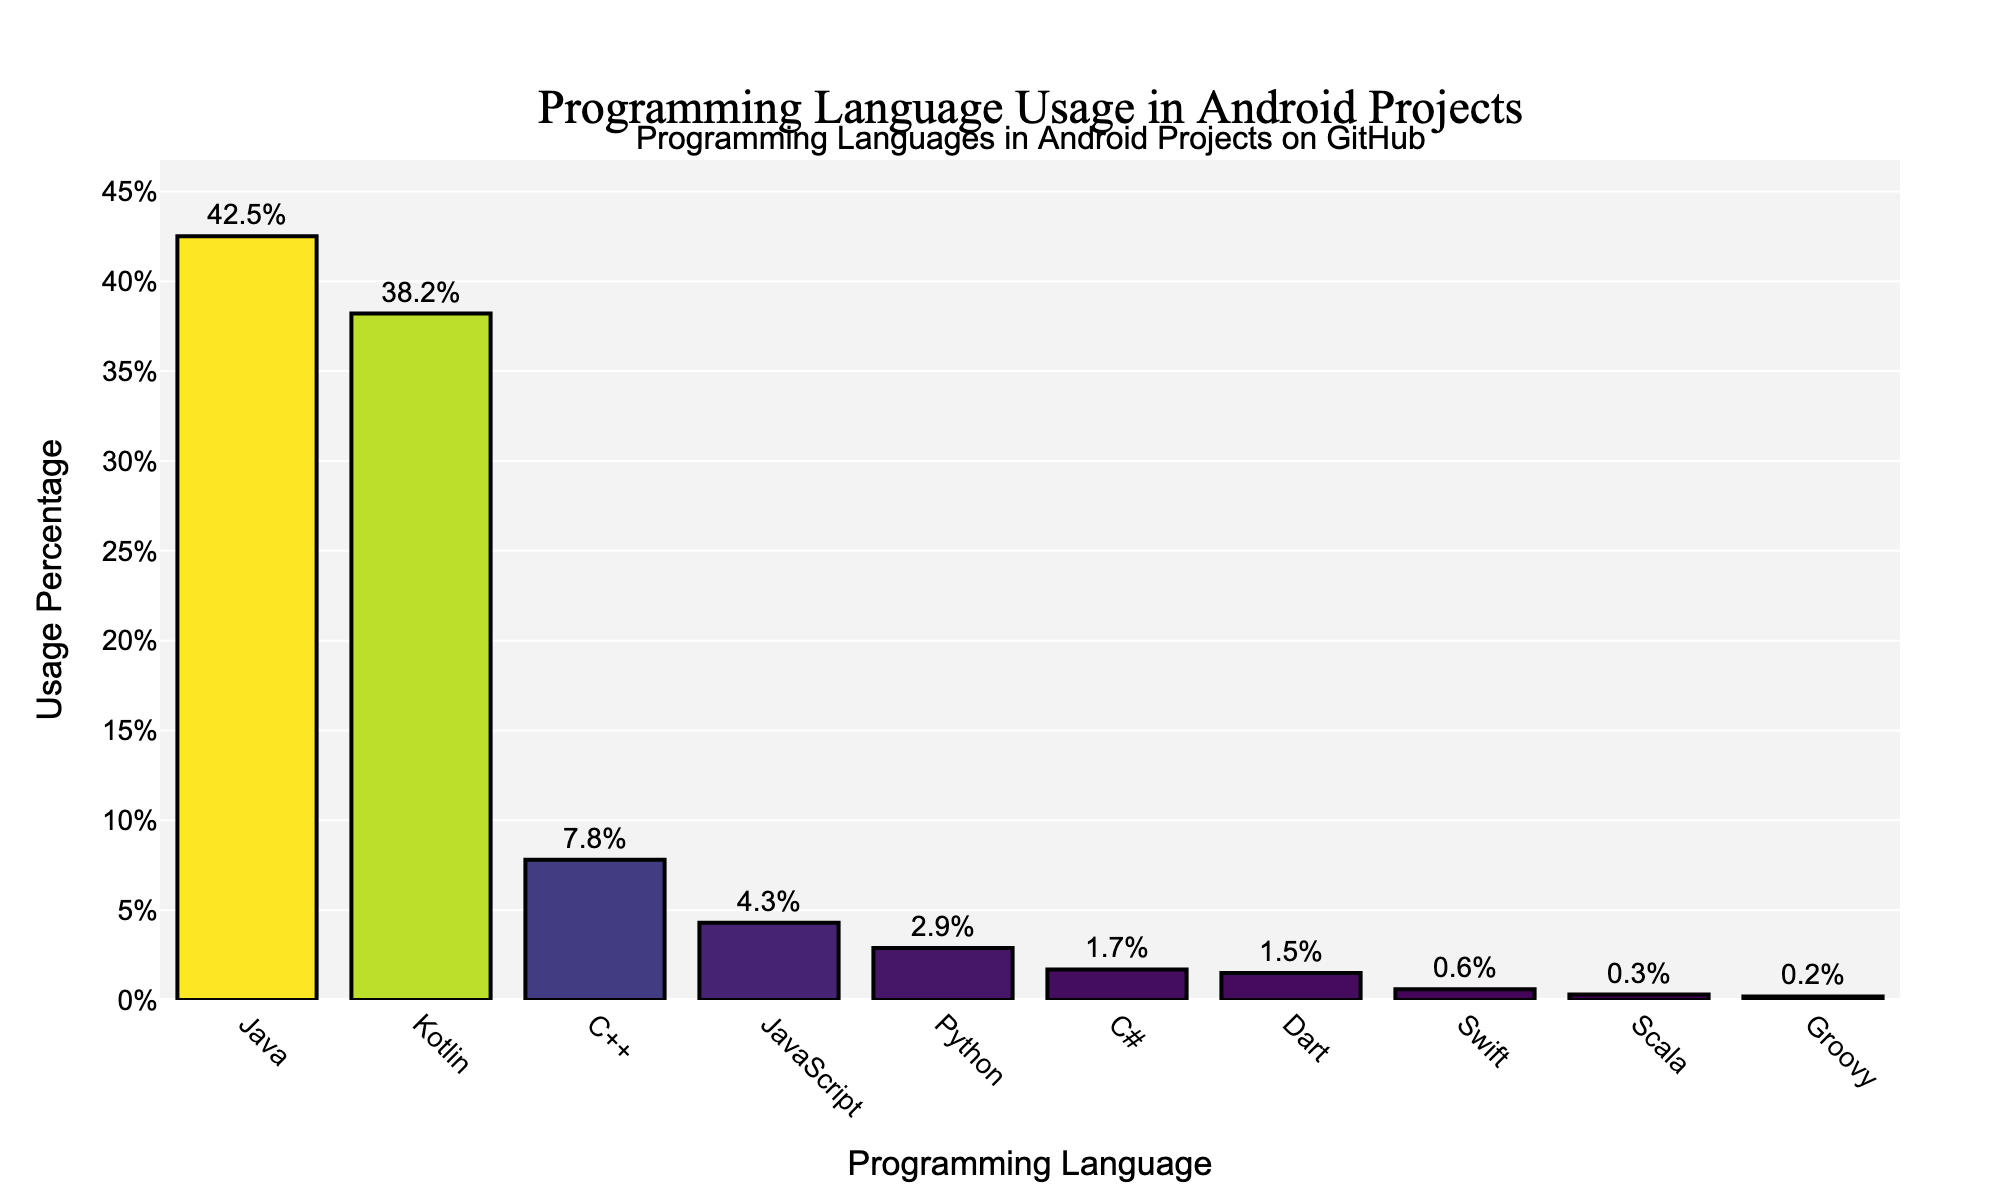Which programming language has the highest usage percentage in Android projects on GitHub? Java has the highest usage percentage as indicated by the tallest bar in the chart.
Answer: Java Which language comes second in terms of usage percentage? The second tallest bar represents the language, which is Kotlin.
Answer: Kotlin Which two languages together make up more than 80% of the usage percentages? Adding the percentages of Java (42.5%) and Kotlin (38.2%) gives 42.5 + 38.2 = 80.7%, which is more than 80%.
Answer: Java and Kotlin What is the difference in usage percentage between Java and Kotlin? The difference is calculated by subtracting Kotlin's percentage (38.2%) from Java's percentage (42.5%): 42.5 - 38.2 = 4.3%.
Answer: 4.3% How many languages have a usage percentage lower than 10%? Counting the bars with heights representing less than 10% gives the languages: C++, JavaScript, Python, C#, Dart, Swift, Scala, and Groovy. That's a total of 8 languages.
Answer: 8 Which language has the smallest usage percentage and what is it? The shortest bar represents Groovy with a usage of 0.2%.
Answer: Groovy, 0.2% Is there a language used at nearly the same percentage as JavaScript? Dart's bar is very close in height to JavaScript's bar; JavaScript has 4.3% and Dart has 1.5%.
Answer: No, Dart is somewhat close but not nearly the same What is the sum of usage percentages for the top three programming languages? Adding the percentages of Java (42.5%), Kotlin (38.2%), and C++ (7.8%): 42.5 + 38.2 + 7.8 = 88.5%.
Answer: 88.5% In terms of visual attributes, which language's bar has a color closer to green among the higher percentages? The Viridis colorscale transitions through green shades, and Kotlin's bar appears next to the green region, closer visually compared to Java.
Answer: Kotlin Considering languages with less than 2% usage, what is their combined percentage? Sum the percentages: C# (1.7%), Dart (1.5%), Swift (0.6%), Scala (0.3%), and Groovy (0.2%): 1.7 + 1.5 + 0.6 + 0.3 + 0.2 = 4.3%.
Answer: 4.3% 